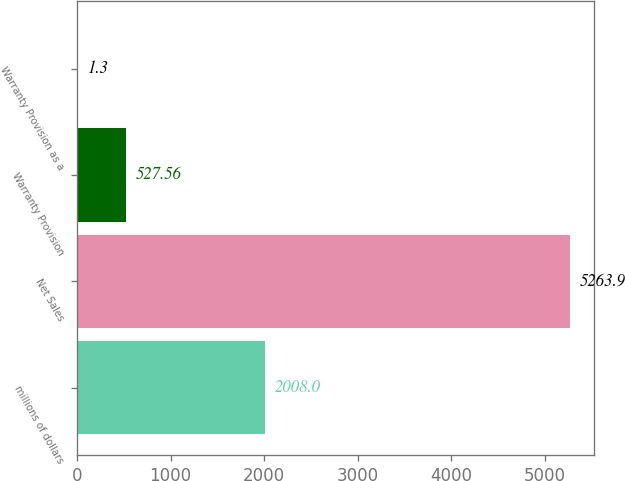<chart> <loc_0><loc_0><loc_500><loc_500><bar_chart><fcel>millions of dollars<fcel>Net Sales<fcel>Warranty Provision<fcel>Warranty Provision as a<nl><fcel>2008<fcel>5263.9<fcel>527.56<fcel>1.3<nl></chart> 